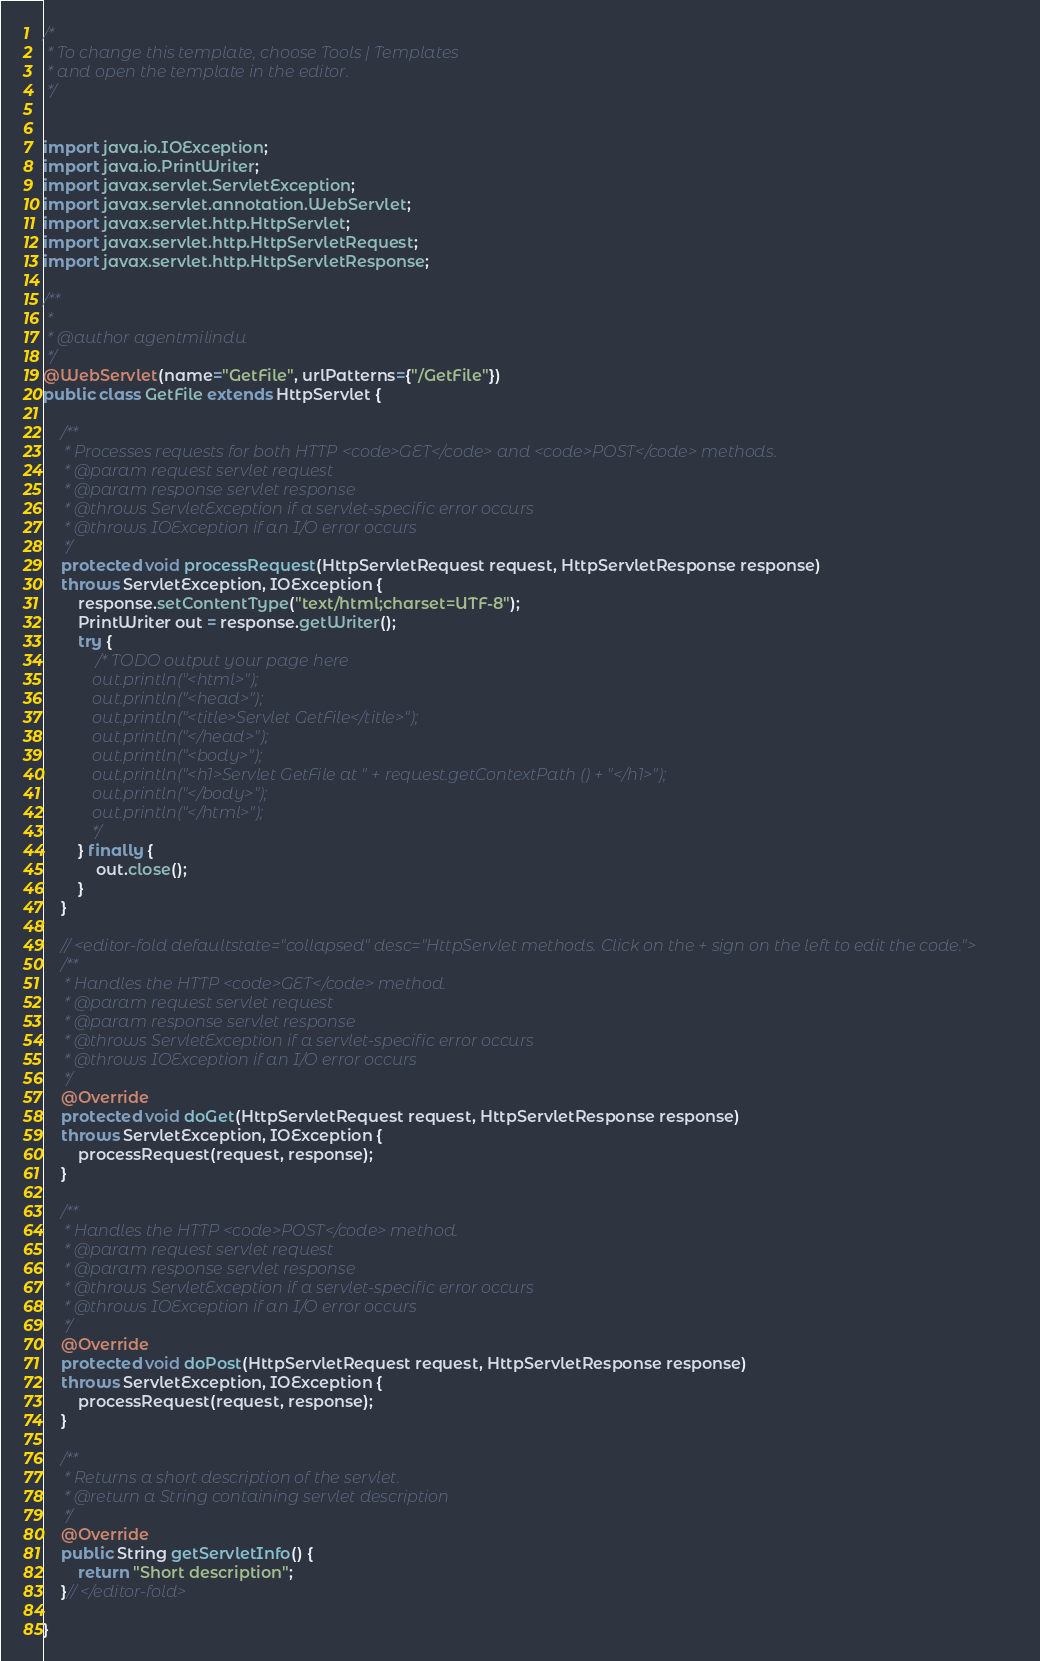Convert code to text. <code><loc_0><loc_0><loc_500><loc_500><_Java_>/*
 * To change this template, choose Tools | Templates
 * and open the template in the editor.
 */


import java.io.IOException;
import java.io.PrintWriter;
import javax.servlet.ServletException;
import javax.servlet.annotation.WebServlet;
import javax.servlet.http.HttpServlet;
import javax.servlet.http.HttpServletRequest;
import javax.servlet.http.HttpServletResponse;

/**
 *
 * @author agentmilindu
 */
@WebServlet(name="GetFile", urlPatterns={"/GetFile"})
public class GetFile extends HttpServlet {
   
    /** 
     * Processes requests for both HTTP <code>GET</code> and <code>POST</code> methods.
     * @param request servlet request
     * @param response servlet response
     * @throws ServletException if a servlet-specific error occurs
     * @throws IOException if an I/O error occurs
     */
    protected void processRequest(HttpServletRequest request, HttpServletResponse response)
    throws ServletException, IOException {
        response.setContentType("text/html;charset=UTF-8");
        PrintWriter out = response.getWriter();
        try {
            /* TODO output your page here
            out.println("<html>");
            out.println("<head>");
            out.println("<title>Servlet GetFile</title>");  
            out.println("</head>");
            out.println("<body>");
            out.println("<h1>Servlet GetFile at " + request.getContextPath () + "</h1>");
            out.println("</body>");
            out.println("</html>");
            */
        } finally { 
            out.close();
        }
    } 

    // <editor-fold defaultstate="collapsed" desc="HttpServlet methods. Click on the + sign on the left to edit the code.">
    /** 
     * Handles the HTTP <code>GET</code> method.
     * @param request servlet request
     * @param response servlet response
     * @throws ServletException if a servlet-specific error occurs
     * @throws IOException if an I/O error occurs
     */
    @Override
    protected void doGet(HttpServletRequest request, HttpServletResponse response)
    throws ServletException, IOException {
        processRequest(request, response);
    } 

    /** 
     * Handles the HTTP <code>POST</code> method.
     * @param request servlet request
     * @param response servlet response
     * @throws ServletException if a servlet-specific error occurs
     * @throws IOException if an I/O error occurs
     */
    @Override
    protected void doPost(HttpServletRequest request, HttpServletResponse response)
    throws ServletException, IOException {
        processRequest(request, response);
    }

    /** 
     * Returns a short description of the servlet.
     * @return a String containing servlet description
     */
    @Override
    public String getServletInfo() {
        return "Short description";
    }// </editor-fold>

}
</code> 